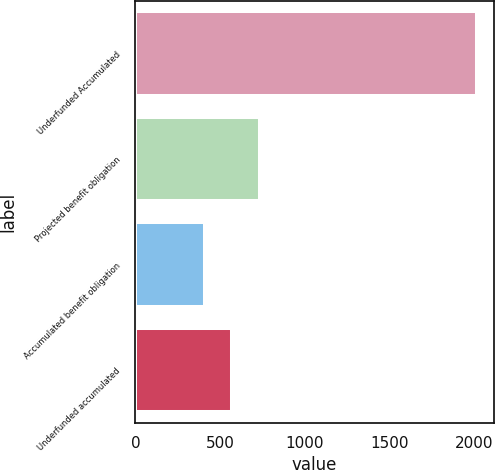Convert chart to OTSL. <chart><loc_0><loc_0><loc_500><loc_500><bar_chart><fcel>Underfunded Accumulated<fcel>Projected benefit obligation<fcel>Accumulated benefit obligation<fcel>Underfunded accumulated<nl><fcel>2016<fcel>732.8<fcel>412<fcel>572.4<nl></chart> 